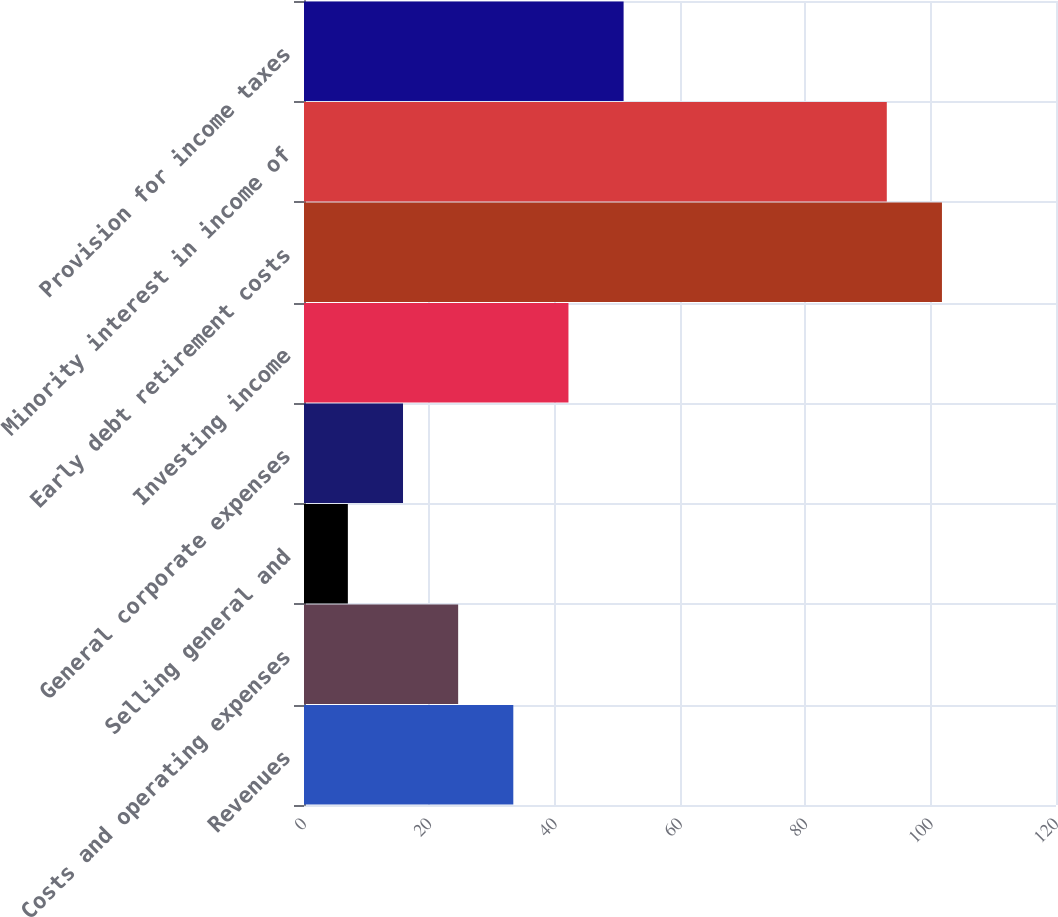<chart> <loc_0><loc_0><loc_500><loc_500><bar_chart><fcel>Revenues<fcel>Costs and operating expenses<fcel>Selling general and<fcel>General corporate expenses<fcel>Investing income<fcel>Early debt retirement costs<fcel>Minority interest in income of<fcel>Provision for income taxes<nl><fcel>33.4<fcel>24.6<fcel>7<fcel>15.8<fcel>42.2<fcel>101.8<fcel>93<fcel>51<nl></chart> 